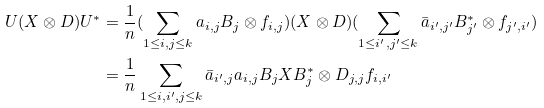Convert formula to latex. <formula><loc_0><loc_0><loc_500><loc_500>U ( X \otimes D ) U ^ { * } & = \frac { 1 } { n } ( \sum _ { 1 \leq i , j \leq k } a _ { i , j } B _ { j } \otimes f _ { i , j } ) ( X \otimes D ) ( \sum _ { 1 \leq i ^ { \prime } , j ^ { \prime } \leq k } \bar { a } _ { i ^ { \prime } , j ^ { \prime } } B _ { j ^ { \prime } } ^ { * } \otimes f _ { j ^ { \prime } , i ^ { \prime } } ) \\ & = \frac { 1 } { n } \sum _ { 1 \leq i , i ^ { \prime } , j \leq k } \bar { a } _ { i ^ { \prime } , j } a _ { i , j } B _ { j } X B _ { j } ^ { * } \otimes D _ { j , j } f _ { i , i ^ { \prime } } \\</formula> 